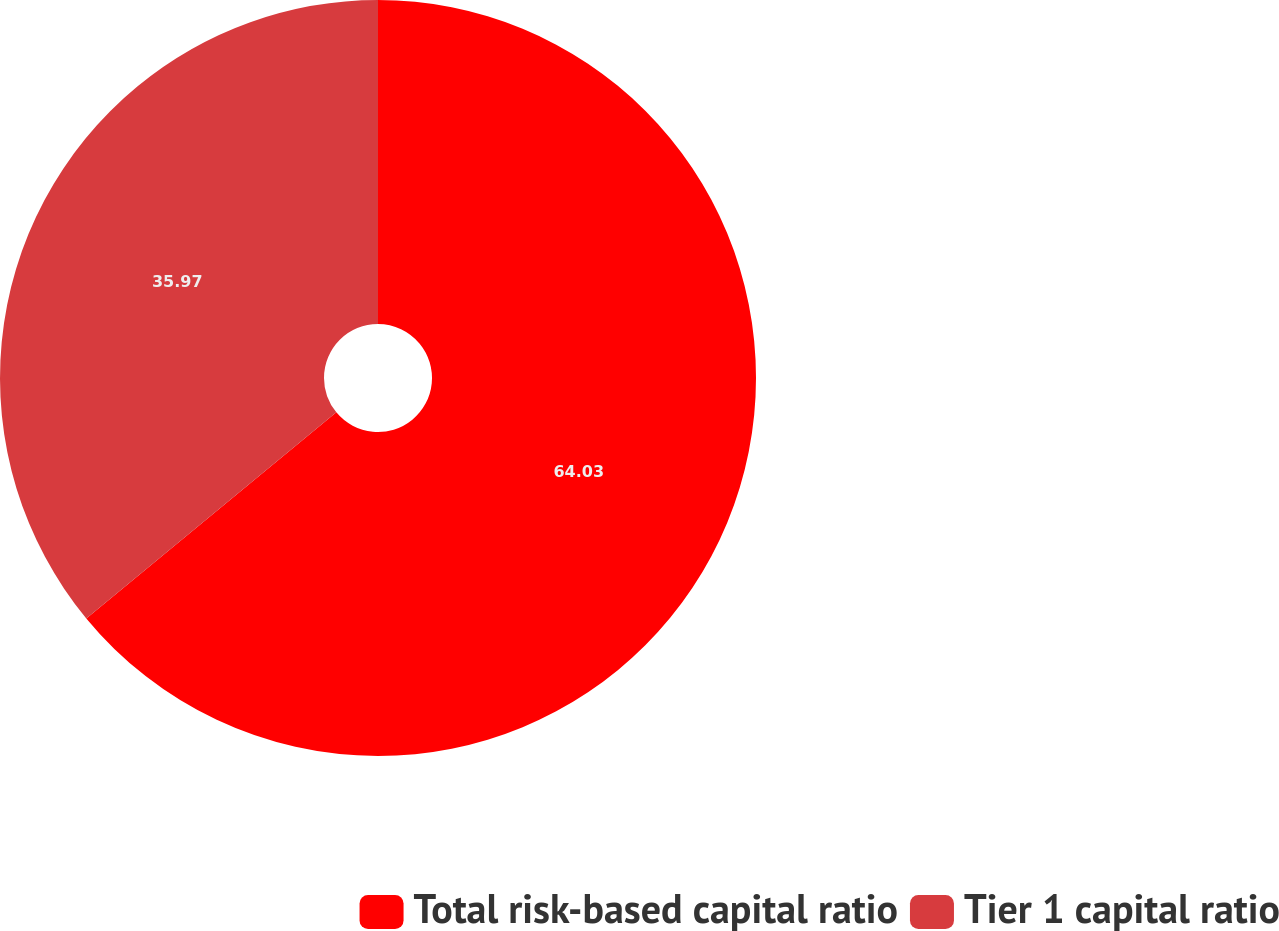Convert chart to OTSL. <chart><loc_0><loc_0><loc_500><loc_500><pie_chart><fcel>Total risk-based capital ratio<fcel>Tier 1 capital ratio<nl><fcel>64.03%<fcel>35.97%<nl></chart> 